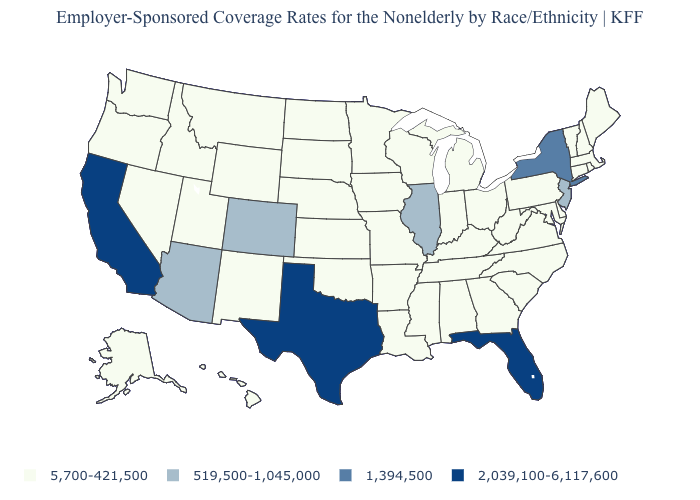Does Connecticut have the highest value in the USA?
Short answer required. No. What is the lowest value in the USA?
Short answer required. 5,700-421,500. Which states have the lowest value in the USA?
Concise answer only. Alabama, Alaska, Arkansas, Connecticut, Delaware, Georgia, Hawaii, Idaho, Indiana, Iowa, Kansas, Kentucky, Louisiana, Maine, Maryland, Massachusetts, Michigan, Minnesota, Mississippi, Missouri, Montana, Nebraska, Nevada, New Hampshire, New Mexico, North Carolina, North Dakota, Ohio, Oklahoma, Oregon, Pennsylvania, Rhode Island, South Carolina, South Dakota, Tennessee, Utah, Vermont, Virginia, Washington, West Virginia, Wisconsin, Wyoming. What is the value of Connecticut?
Quick response, please. 5,700-421,500. Name the states that have a value in the range 5,700-421,500?
Give a very brief answer. Alabama, Alaska, Arkansas, Connecticut, Delaware, Georgia, Hawaii, Idaho, Indiana, Iowa, Kansas, Kentucky, Louisiana, Maine, Maryland, Massachusetts, Michigan, Minnesota, Mississippi, Missouri, Montana, Nebraska, Nevada, New Hampshire, New Mexico, North Carolina, North Dakota, Ohio, Oklahoma, Oregon, Pennsylvania, Rhode Island, South Carolina, South Dakota, Tennessee, Utah, Vermont, Virginia, Washington, West Virginia, Wisconsin, Wyoming. What is the value of South Dakota?
Answer briefly. 5,700-421,500. Does New York have the highest value in the Northeast?
Answer briefly. Yes. What is the value of New Hampshire?
Write a very short answer. 5,700-421,500. What is the highest value in states that border Pennsylvania?
Quick response, please. 1,394,500. Does Vermont have the lowest value in the USA?
Short answer required. Yes. Does the first symbol in the legend represent the smallest category?
Quick response, please. Yes. Among the states that border Virginia , which have the highest value?
Be succinct. Kentucky, Maryland, North Carolina, Tennessee, West Virginia. Name the states that have a value in the range 519,500-1,045,000?
Give a very brief answer. Arizona, Colorado, Illinois, New Jersey. Is the legend a continuous bar?
Concise answer only. No. Name the states that have a value in the range 5,700-421,500?
Answer briefly. Alabama, Alaska, Arkansas, Connecticut, Delaware, Georgia, Hawaii, Idaho, Indiana, Iowa, Kansas, Kentucky, Louisiana, Maine, Maryland, Massachusetts, Michigan, Minnesota, Mississippi, Missouri, Montana, Nebraska, Nevada, New Hampshire, New Mexico, North Carolina, North Dakota, Ohio, Oklahoma, Oregon, Pennsylvania, Rhode Island, South Carolina, South Dakota, Tennessee, Utah, Vermont, Virginia, Washington, West Virginia, Wisconsin, Wyoming. 